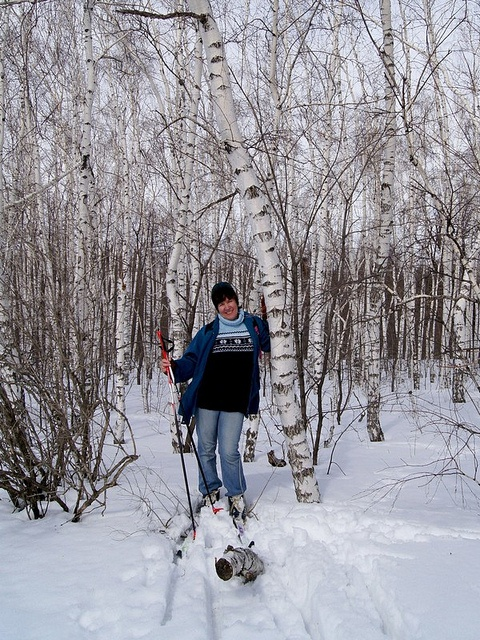Describe the objects in this image and their specific colors. I can see people in lightgray, black, gray, and navy tones and skis in lightgray, darkgray, and gray tones in this image. 